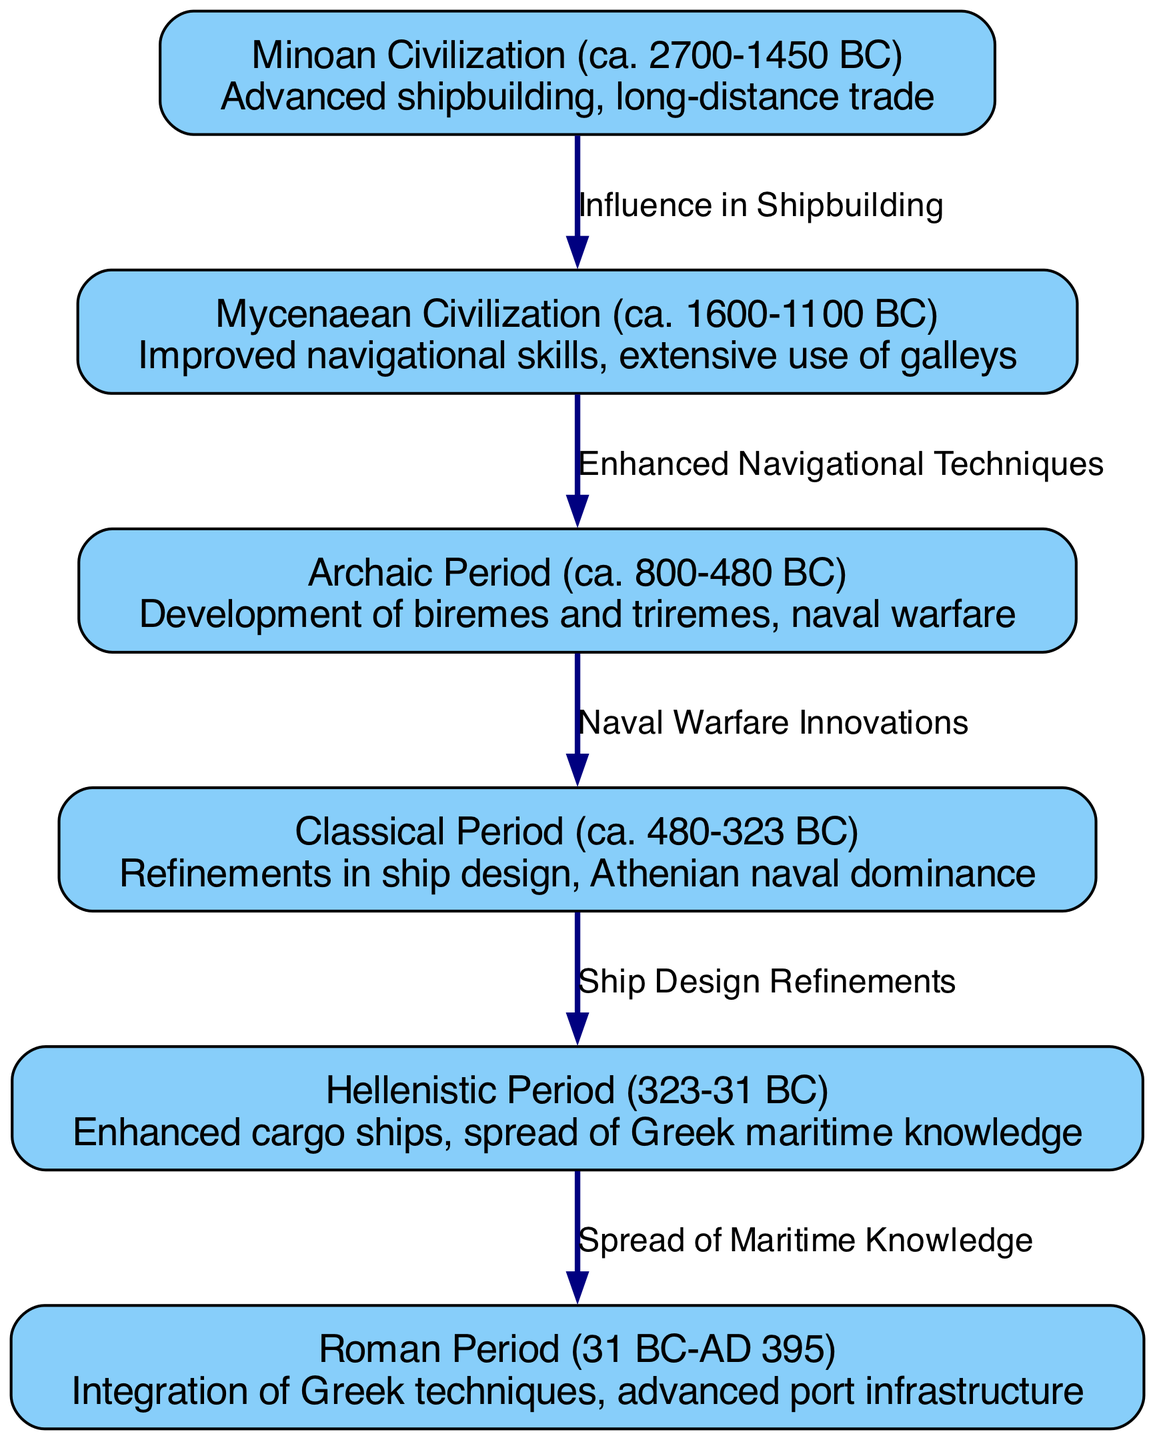What is the time span of the Minoan Civilization? The Minoan Civilization is dated from about 2700 BC to 1450 BC, which provides the time frame for its existence as indicated in the diagram.
Answer: ca. 2700-1450 BC How many nodes are present in the diagram? The diagram features a total of six distinct nodes, each representing a significant period in the evolution of Greek seafaring techniques.
Answer: 6 What was a key advancement during the Archaic Period? The diagram indicates that the Archaic Period was marked by the development of biremes and triremes, which were essential advancements in naval ship design.
Answer: Biremes and triremes Which civilization had an influence on shipbuilding techniques? The diagram shows that the Minoan Civilization influenced the subsequent Mycenaean Civilization in shipbuilding practices.
Answer: Minoan Civilization What was a significant change introduced from the Classical Period to the Hellenistic Period? The transition from the Classical Period to the Hellenistic Period was characterized by refinements in ship design, as indicated in the diagram.
Answer: Ship Design Refinements What type of ship technology was primarily used by the Mycenaean Civilization? The Mycenaean Civilization is noted in the diagram for its extensive use of galleys, a specific type of ship technology utilized during that time.
Answer: Galleys Describe the relationship between the Classical and Hellenistic Periods. The edge labeled "Ship Design Refinements" illustrates that innovations from the Classical Period directly influenced developments in the Hellenistic Period regarding ship technology and design.
Answer: Ship Design Refinements What was integrated during the Roman Period regarding Greek seafaring? The diagram highlights that the Roman Period involved the integration of Greek techniques alongside advancements in port infrastructure, indicating a blending of technologies.
Answer: Integration of Greek techniques 